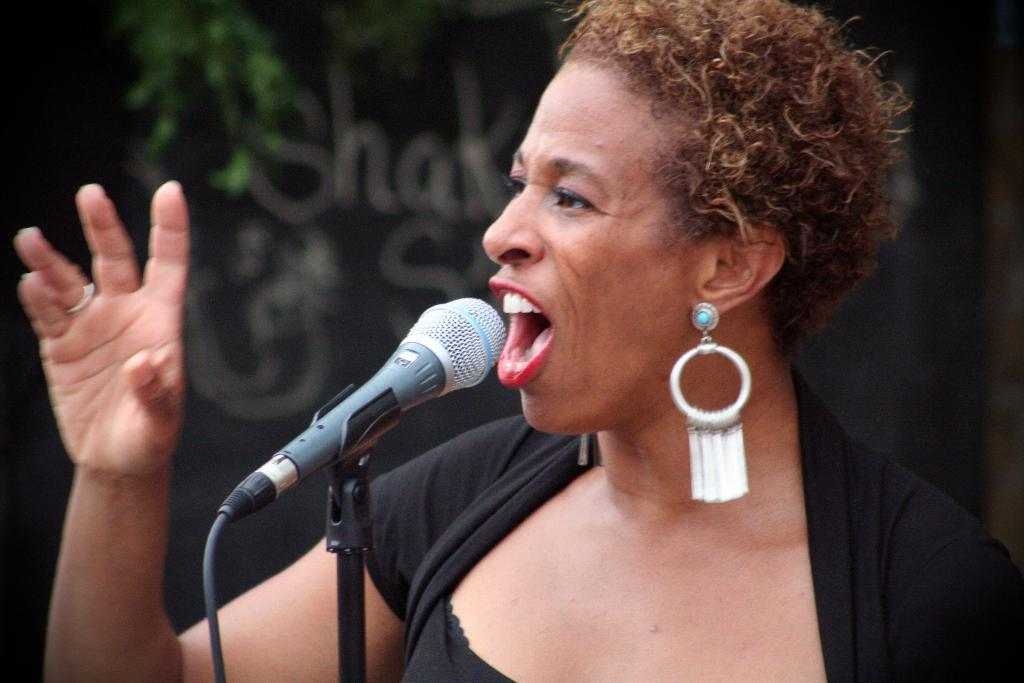Who is the main subject in the image? There is a woman in the image. What is the woman doing in the image? The woman is standing near a mic. What can be observed about the background of the image? The background of the image is dark. How many kittens are crawling on the woman's shoulder in the image? There are no kittens present in the image. What type of beetle can be seen in the background of the image? There is no beetle visible in the image, as the background is dark. 